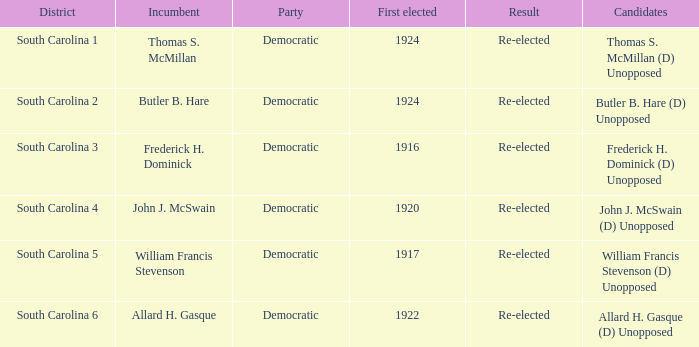What is the party for south carolina 3? Democratic. 